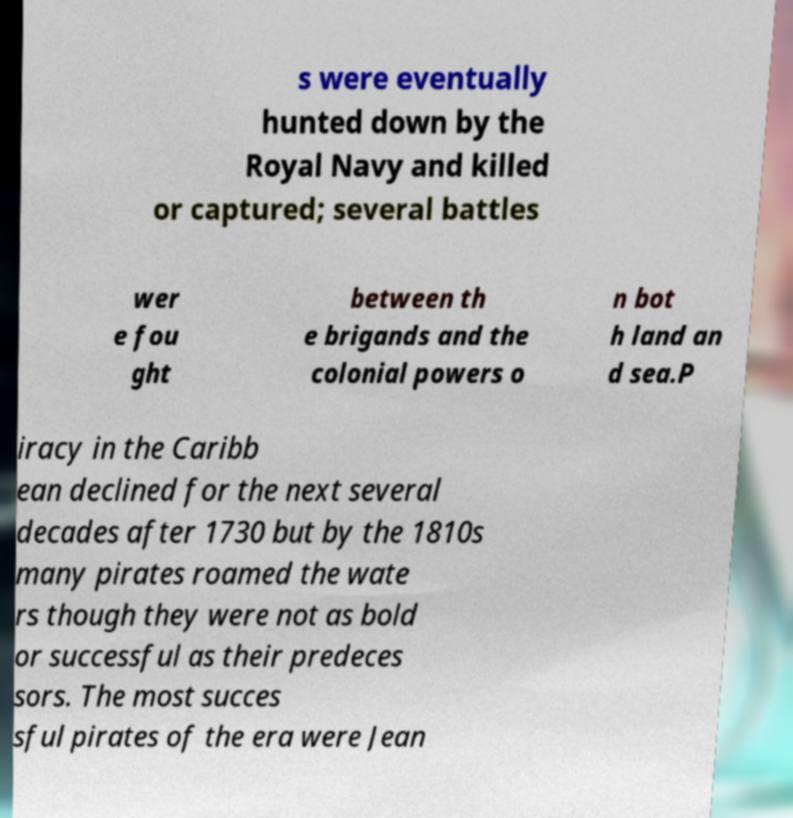Please read and relay the text visible in this image. What does it say? s were eventually hunted down by the Royal Navy and killed or captured; several battles wer e fou ght between th e brigands and the colonial powers o n bot h land an d sea.P iracy in the Caribb ean declined for the next several decades after 1730 but by the 1810s many pirates roamed the wate rs though they were not as bold or successful as their predeces sors. The most succes sful pirates of the era were Jean 